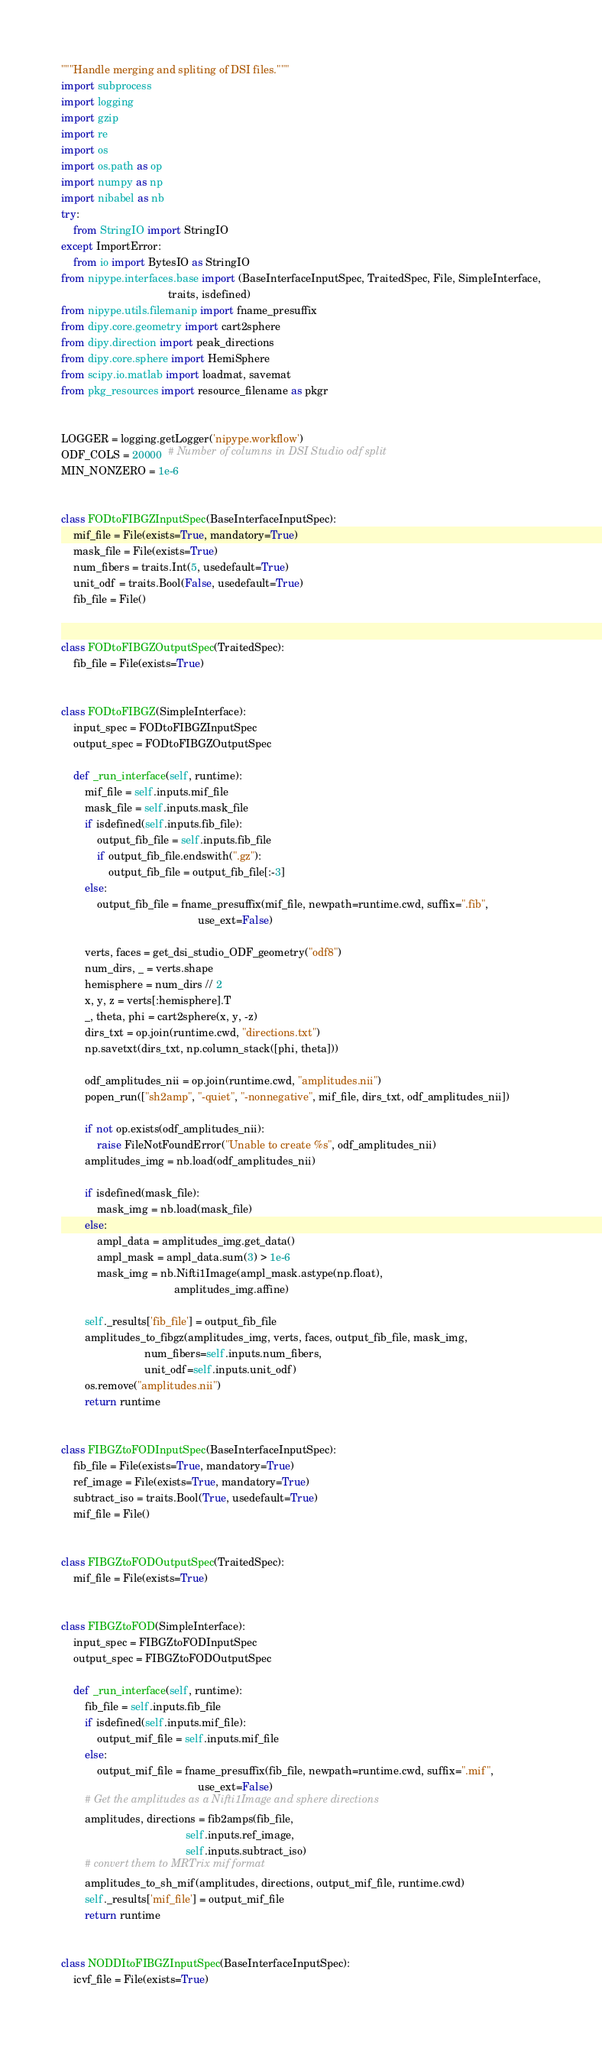<code> <loc_0><loc_0><loc_500><loc_500><_Python_>
"""Handle merging and spliting of DSI files."""
import subprocess
import logging
import gzip
import re
import os
import os.path as op
import numpy as np
import nibabel as nb
try:
    from StringIO import StringIO
except ImportError:
    from io import BytesIO as StringIO
from nipype.interfaces.base import (BaseInterfaceInputSpec, TraitedSpec, File, SimpleInterface,
                                    traits, isdefined)
from nipype.utils.filemanip import fname_presuffix
from dipy.core.geometry import cart2sphere
from dipy.direction import peak_directions
from dipy.core.sphere import HemiSphere
from scipy.io.matlab import loadmat, savemat
from pkg_resources import resource_filename as pkgr


LOGGER = logging.getLogger('nipype.workflow')
ODF_COLS = 20000  # Number of columns in DSI Studio odf split
MIN_NONZERO = 1e-6


class FODtoFIBGZInputSpec(BaseInterfaceInputSpec):
    mif_file = File(exists=True, mandatory=True)
    mask_file = File(exists=True)
    num_fibers = traits.Int(5, usedefault=True)
    unit_odf = traits.Bool(False, usedefault=True)
    fib_file = File()


class FODtoFIBGZOutputSpec(TraitedSpec):
    fib_file = File(exists=True)


class FODtoFIBGZ(SimpleInterface):
    input_spec = FODtoFIBGZInputSpec
    output_spec = FODtoFIBGZOutputSpec

    def _run_interface(self, runtime):
        mif_file = self.inputs.mif_file
        mask_file = self.inputs.mask_file
        if isdefined(self.inputs.fib_file):
            output_fib_file = self.inputs.fib_file
            if output_fib_file.endswith(".gz"):
                output_fib_file = output_fib_file[:-3]
        else:
            output_fib_file = fname_presuffix(mif_file, newpath=runtime.cwd, suffix=".fib",
                                              use_ext=False)

        verts, faces = get_dsi_studio_ODF_geometry("odf8")
        num_dirs, _ = verts.shape
        hemisphere = num_dirs // 2
        x, y, z = verts[:hemisphere].T
        _, theta, phi = cart2sphere(x, y, -z)
        dirs_txt = op.join(runtime.cwd, "directions.txt")
        np.savetxt(dirs_txt, np.column_stack([phi, theta]))

        odf_amplitudes_nii = op.join(runtime.cwd, "amplitudes.nii")
        popen_run(["sh2amp", "-quiet", "-nonnegative", mif_file, dirs_txt, odf_amplitudes_nii])

        if not op.exists(odf_amplitudes_nii):
            raise FileNotFoundError("Unable to create %s", odf_amplitudes_nii)
        amplitudes_img = nb.load(odf_amplitudes_nii)

        if isdefined(mask_file):
            mask_img = nb.load(mask_file)
        else:
            ampl_data = amplitudes_img.get_data()
            ampl_mask = ampl_data.sum(3) > 1e-6
            mask_img = nb.Nifti1Image(ampl_mask.astype(np.float),
                                      amplitudes_img.affine)

        self._results['fib_file'] = output_fib_file
        amplitudes_to_fibgz(amplitudes_img, verts, faces, output_fib_file, mask_img,
                            num_fibers=self.inputs.num_fibers,
                            unit_odf=self.inputs.unit_odf)
        os.remove("amplitudes.nii")
        return runtime


class FIBGZtoFODInputSpec(BaseInterfaceInputSpec):
    fib_file = File(exists=True, mandatory=True)
    ref_image = File(exists=True, mandatory=True)
    subtract_iso = traits.Bool(True, usedefault=True)
    mif_file = File()


class FIBGZtoFODOutputSpec(TraitedSpec):
    mif_file = File(exists=True)


class FIBGZtoFOD(SimpleInterface):
    input_spec = FIBGZtoFODInputSpec
    output_spec = FIBGZtoFODOutputSpec

    def _run_interface(self, runtime):
        fib_file = self.inputs.fib_file
        if isdefined(self.inputs.mif_file):
            output_mif_file = self.inputs.mif_file
        else:
            output_mif_file = fname_presuffix(fib_file, newpath=runtime.cwd, suffix=".mif",
                                              use_ext=False)
        # Get the amplitudes as a Nifti1Image and sphere directions
        amplitudes, directions = fib2amps(fib_file,
                                          self.inputs.ref_image,
                                          self.inputs.subtract_iso)
        # convert them to MRTrix mif format
        amplitudes_to_sh_mif(amplitudes, directions, output_mif_file, runtime.cwd)
        self._results['mif_file'] = output_mif_file
        return runtime


class NODDItoFIBGZInputSpec(BaseInterfaceInputSpec):
    icvf_file = File(exists=True)</code> 